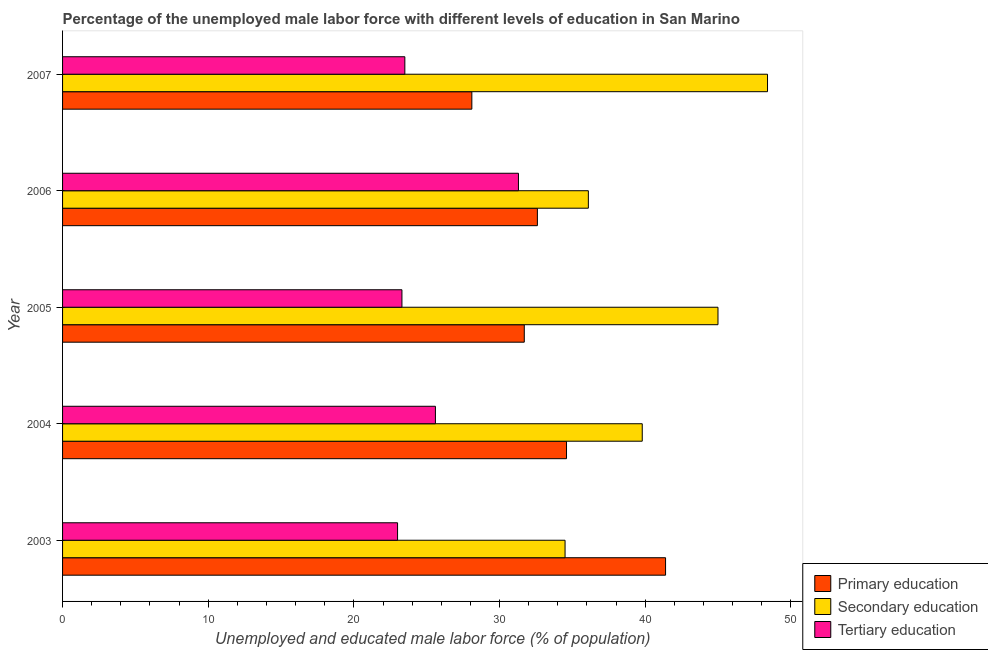Are the number of bars on each tick of the Y-axis equal?
Offer a terse response. Yes. In how many cases, is the number of bars for a given year not equal to the number of legend labels?
Offer a very short reply. 0. What is the percentage of male labor force who received secondary education in 2005?
Provide a succinct answer. 45. Across all years, what is the maximum percentage of male labor force who received primary education?
Your answer should be compact. 41.4. Across all years, what is the minimum percentage of male labor force who received secondary education?
Offer a very short reply. 34.5. In which year was the percentage of male labor force who received tertiary education maximum?
Provide a short and direct response. 2006. What is the total percentage of male labor force who received secondary education in the graph?
Give a very brief answer. 203.8. What is the difference between the percentage of male labor force who received tertiary education in 2003 and the percentage of male labor force who received primary education in 2005?
Keep it short and to the point. -8.7. What is the average percentage of male labor force who received tertiary education per year?
Provide a succinct answer. 25.34. In the year 2006, what is the difference between the percentage of male labor force who received primary education and percentage of male labor force who received tertiary education?
Your response must be concise. 1.3. What is the ratio of the percentage of male labor force who received primary education in 2004 to that in 2006?
Give a very brief answer. 1.06. Is the percentage of male labor force who received primary education in 2005 less than that in 2006?
Your answer should be compact. Yes. Is the difference between the percentage of male labor force who received primary education in 2003 and 2007 greater than the difference between the percentage of male labor force who received secondary education in 2003 and 2007?
Offer a terse response. Yes. What is the difference between the highest and the second highest percentage of male labor force who received secondary education?
Your response must be concise. 3.4. What is the difference between the highest and the lowest percentage of male labor force who received primary education?
Provide a short and direct response. 13.3. In how many years, is the percentage of male labor force who received tertiary education greater than the average percentage of male labor force who received tertiary education taken over all years?
Keep it short and to the point. 2. Is the sum of the percentage of male labor force who received secondary education in 2003 and 2006 greater than the maximum percentage of male labor force who received tertiary education across all years?
Ensure brevity in your answer.  Yes. What does the 2nd bar from the top in 2004 represents?
Provide a succinct answer. Secondary education. What does the 3rd bar from the bottom in 2006 represents?
Give a very brief answer. Tertiary education. Are all the bars in the graph horizontal?
Provide a succinct answer. Yes. How many years are there in the graph?
Ensure brevity in your answer.  5. Are the values on the major ticks of X-axis written in scientific E-notation?
Offer a very short reply. No. Does the graph contain grids?
Ensure brevity in your answer.  No. Where does the legend appear in the graph?
Your answer should be compact. Bottom right. How many legend labels are there?
Make the answer very short. 3. What is the title of the graph?
Your answer should be compact. Percentage of the unemployed male labor force with different levels of education in San Marino. Does "Travel services" appear as one of the legend labels in the graph?
Keep it short and to the point. No. What is the label or title of the X-axis?
Your answer should be very brief. Unemployed and educated male labor force (% of population). What is the Unemployed and educated male labor force (% of population) of Primary education in 2003?
Keep it short and to the point. 41.4. What is the Unemployed and educated male labor force (% of population) in Secondary education in 2003?
Keep it short and to the point. 34.5. What is the Unemployed and educated male labor force (% of population) of Tertiary education in 2003?
Make the answer very short. 23. What is the Unemployed and educated male labor force (% of population) of Primary education in 2004?
Your answer should be compact. 34.6. What is the Unemployed and educated male labor force (% of population) of Secondary education in 2004?
Offer a very short reply. 39.8. What is the Unemployed and educated male labor force (% of population) in Tertiary education in 2004?
Give a very brief answer. 25.6. What is the Unemployed and educated male labor force (% of population) of Primary education in 2005?
Ensure brevity in your answer.  31.7. What is the Unemployed and educated male labor force (% of population) in Tertiary education in 2005?
Provide a short and direct response. 23.3. What is the Unemployed and educated male labor force (% of population) in Primary education in 2006?
Make the answer very short. 32.6. What is the Unemployed and educated male labor force (% of population) in Secondary education in 2006?
Give a very brief answer. 36.1. What is the Unemployed and educated male labor force (% of population) of Tertiary education in 2006?
Provide a succinct answer. 31.3. What is the Unemployed and educated male labor force (% of population) in Primary education in 2007?
Your response must be concise. 28.1. What is the Unemployed and educated male labor force (% of population) in Secondary education in 2007?
Provide a short and direct response. 48.4. What is the Unemployed and educated male labor force (% of population) of Tertiary education in 2007?
Your answer should be very brief. 23.5. Across all years, what is the maximum Unemployed and educated male labor force (% of population) in Primary education?
Your answer should be compact. 41.4. Across all years, what is the maximum Unemployed and educated male labor force (% of population) in Secondary education?
Make the answer very short. 48.4. Across all years, what is the maximum Unemployed and educated male labor force (% of population) in Tertiary education?
Offer a terse response. 31.3. Across all years, what is the minimum Unemployed and educated male labor force (% of population) in Primary education?
Ensure brevity in your answer.  28.1. Across all years, what is the minimum Unemployed and educated male labor force (% of population) in Secondary education?
Make the answer very short. 34.5. What is the total Unemployed and educated male labor force (% of population) of Primary education in the graph?
Offer a terse response. 168.4. What is the total Unemployed and educated male labor force (% of population) in Secondary education in the graph?
Your response must be concise. 203.8. What is the total Unemployed and educated male labor force (% of population) of Tertiary education in the graph?
Keep it short and to the point. 126.7. What is the difference between the Unemployed and educated male labor force (% of population) in Primary education in 2003 and that in 2004?
Provide a short and direct response. 6.8. What is the difference between the Unemployed and educated male labor force (% of population) in Tertiary education in 2003 and that in 2004?
Provide a succinct answer. -2.6. What is the difference between the Unemployed and educated male labor force (% of population) in Secondary education in 2003 and that in 2005?
Offer a very short reply. -10.5. What is the difference between the Unemployed and educated male labor force (% of population) in Primary education in 2003 and that in 2006?
Your answer should be compact. 8.8. What is the difference between the Unemployed and educated male labor force (% of population) in Primary education in 2003 and that in 2007?
Keep it short and to the point. 13.3. What is the difference between the Unemployed and educated male labor force (% of population) of Primary education in 2004 and that in 2005?
Your response must be concise. 2.9. What is the difference between the Unemployed and educated male labor force (% of population) in Secondary education in 2004 and that in 2005?
Give a very brief answer. -5.2. What is the difference between the Unemployed and educated male labor force (% of population) in Tertiary education in 2004 and that in 2005?
Offer a very short reply. 2.3. What is the difference between the Unemployed and educated male labor force (% of population) in Primary education in 2004 and that in 2006?
Offer a very short reply. 2. What is the difference between the Unemployed and educated male labor force (% of population) in Secondary education in 2004 and that in 2006?
Provide a short and direct response. 3.7. What is the difference between the Unemployed and educated male labor force (% of population) of Primary education in 2004 and that in 2007?
Make the answer very short. 6.5. What is the difference between the Unemployed and educated male labor force (% of population) of Primary education in 2005 and that in 2006?
Give a very brief answer. -0.9. What is the difference between the Unemployed and educated male labor force (% of population) of Secondary education in 2005 and that in 2006?
Ensure brevity in your answer.  8.9. What is the difference between the Unemployed and educated male labor force (% of population) in Primary education in 2005 and that in 2007?
Give a very brief answer. 3.6. What is the difference between the Unemployed and educated male labor force (% of population) of Secondary education in 2005 and that in 2007?
Your answer should be compact. -3.4. What is the difference between the Unemployed and educated male labor force (% of population) in Primary education in 2006 and that in 2007?
Your answer should be compact. 4.5. What is the difference between the Unemployed and educated male labor force (% of population) of Secondary education in 2006 and that in 2007?
Your answer should be compact. -12.3. What is the difference between the Unemployed and educated male labor force (% of population) in Primary education in 2003 and the Unemployed and educated male labor force (% of population) in Secondary education in 2004?
Your answer should be very brief. 1.6. What is the difference between the Unemployed and educated male labor force (% of population) in Primary education in 2003 and the Unemployed and educated male labor force (% of population) in Tertiary education in 2004?
Offer a terse response. 15.8. What is the difference between the Unemployed and educated male labor force (% of population) of Primary education in 2003 and the Unemployed and educated male labor force (% of population) of Tertiary education in 2005?
Provide a succinct answer. 18.1. What is the difference between the Unemployed and educated male labor force (% of population) of Secondary education in 2003 and the Unemployed and educated male labor force (% of population) of Tertiary education in 2005?
Provide a short and direct response. 11.2. What is the difference between the Unemployed and educated male labor force (% of population) in Primary education in 2003 and the Unemployed and educated male labor force (% of population) in Secondary education in 2006?
Your answer should be very brief. 5.3. What is the difference between the Unemployed and educated male labor force (% of population) of Primary education in 2003 and the Unemployed and educated male labor force (% of population) of Tertiary education in 2006?
Give a very brief answer. 10.1. What is the difference between the Unemployed and educated male labor force (% of population) in Primary education in 2003 and the Unemployed and educated male labor force (% of population) in Secondary education in 2007?
Provide a short and direct response. -7. What is the difference between the Unemployed and educated male labor force (% of population) of Primary education in 2003 and the Unemployed and educated male labor force (% of population) of Tertiary education in 2007?
Offer a very short reply. 17.9. What is the difference between the Unemployed and educated male labor force (% of population) of Primary education in 2004 and the Unemployed and educated male labor force (% of population) of Secondary education in 2005?
Give a very brief answer. -10.4. What is the difference between the Unemployed and educated male labor force (% of population) in Secondary education in 2004 and the Unemployed and educated male labor force (% of population) in Tertiary education in 2006?
Provide a succinct answer. 8.5. What is the difference between the Unemployed and educated male labor force (% of population) in Secondary education in 2004 and the Unemployed and educated male labor force (% of population) in Tertiary education in 2007?
Ensure brevity in your answer.  16.3. What is the difference between the Unemployed and educated male labor force (% of population) of Primary education in 2005 and the Unemployed and educated male labor force (% of population) of Tertiary education in 2006?
Offer a very short reply. 0.4. What is the difference between the Unemployed and educated male labor force (% of population) in Primary education in 2005 and the Unemployed and educated male labor force (% of population) in Secondary education in 2007?
Provide a succinct answer. -16.7. What is the difference between the Unemployed and educated male labor force (% of population) in Primary education in 2005 and the Unemployed and educated male labor force (% of population) in Tertiary education in 2007?
Keep it short and to the point. 8.2. What is the difference between the Unemployed and educated male labor force (% of population) in Secondary education in 2005 and the Unemployed and educated male labor force (% of population) in Tertiary education in 2007?
Keep it short and to the point. 21.5. What is the difference between the Unemployed and educated male labor force (% of population) of Primary education in 2006 and the Unemployed and educated male labor force (% of population) of Secondary education in 2007?
Your response must be concise. -15.8. What is the difference between the Unemployed and educated male labor force (% of population) in Secondary education in 2006 and the Unemployed and educated male labor force (% of population) in Tertiary education in 2007?
Provide a succinct answer. 12.6. What is the average Unemployed and educated male labor force (% of population) in Primary education per year?
Your answer should be very brief. 33.68. What is the average Unemployed and educated male labor force (% of population) in Secondary education per year?
Give a very brief answer. 40.76. What is the average Unemployed and educated male labor force (% of population) of Tertiary education per year?
Your answer should be very brief. 25.34. In the year 2003, what is the difference between the Unemployed and educated male labor force (% of population) in Primary education and Unemployed and educated male labor force (% of population) in Secondary education?
Your answer should be compact. 6.9. In the year 2004, what is the difference between the Unemployed and educated male labor force (% of population) of Primary education and Unemployed and educated male labor force (% of population) of Secondary education?
Your answer should be compact. -5.2. In the year 2004, what is the difference between the Unemployed and educated male labor force (% of population) in Secondary education and Unemployed and educated male labor force (% of population) in Tertiary education?
Offer a very short reply. 14.2. In the year 2005, what is the difference between the Unemployed and educated male labor force (% of population) in Primary education and Unemployed and educated male labor force (% of population) in Secondary education?
Provide a short and direct response. -13.3. In the year 2005, what is the difference between the Unemployed and educated male labor force (% of population) in Primary education and Unemployed and educated male labor force (% of population) in Tertiary education?
Ensure brevity in your answer.  8.4. In the year 2005, what is the difference between the Unemployed and educated male labor force (% of population) of Secondary education and Unemployed and educated male labor force (% of population) of Tertiary education?
Provide a succinct answer. 21.7. In the year 2006, what is the difference between the Unemployed and educated male labor force (% of population) in Primary education and Unemployed and educated male labor force (% of population) in Secondary education?
Give a very brief answer. -3.5. In the year 2007, what is the difference between the Unemployed and educated male labor force (% of population) in Primary education and Unemployed and educated male labor force (% of population) in Secondary education?
Ensure brevity in your answer.  -20.3. In the year 2007, what is the difference between the Unemployed and educated male labor force (% of population) of Secondary education and Unemployed and educated male labor force (% of population) of Tertiary education?
Ensure brevity in your answer.  24.9. What is the ratio of the Unemployed and educated male labor force (% of population) of Primary education in 2003 to that in 2004?
Give a very brief answer. 1.2. What is the ratio of the Unemployed and educated male labor force (% of population) in Secondary education in 2003 to that in 2004?
Your answer should be very brief. 0.87. What is the ratio of the Unemployed and educated male labor force (% of population) of Tertiary education in 2003 to that in 2004?
Offer a terse response. 0.9. What is the ratio of the Unemployed and educated male labor force (% of population) of Primary education in 2003 to that in 2005?
Your answer should be very brief. 1.31. What is the ratio of the Unemployed and educated male labor force (% of population) of Secondary education in 2003 to that in 2005?
Offer a terse response. 0.77. What is the ratio of the Unemployed and educated male labor force (% of population) in Tertiary education in 2003 to that in 2005?
Your answer should be very brief. 0.99. What is the ratio of the Unemployed and educated male labor force (% of population) in Primary education in 2003 to that in 2006?
Make the answer very short. 1.27. What is the ratio of the Unemployed and educated male labor force (% of population) of Secondary education in 2003 to that in 2006?
Offer a terse response. 0.96. What is the ratio of the Unemployed and educated male labor force (% of population) of Tertiary education in 2003 to that in 2006?
Provide a short and direct response. 0.73. What is the ratio of the Unemployed and educated male labor force (% of population) of Primary education in 2003 to that in 2007?
Make the answer very short. 1.47. What is the ratio of the Unemployed and educated male labor force (% of population) in Secondary education in 2003 to that in 2007?
Provide a succinct answer. 0.71. What is the ratio of the Unemployed and educated male labor force (% of population) of Tertiary education in 2003 to that in 2007?
Provide a succinct answer. 0.98. What is the ratio of the Unemployed and educated male labor force (% of population) of Primary education in 2004 to that in 2005?
Your answer should be compact. 1.09. What is the ratio of the Unemployed and educated male labor force (% of population) of Secondary education in 2004 to that in 2005?
Provide a succinct answer. 0.88. What is the ratio of the Unemployed and educated male labor force (% of population) in Tertiary education in 2004 to that in 2005?
Keep it short and to the point. 1.1. What is the ratio of the Unemployed and educated male labor force (% of population) in Primary education in 2004 to that in 2006?
Provide a succinct answer. 1.06. What is the ratio of the Unemployed and educated male labor force (% of population) of Secondary education in 2004 to that in 2006?
Your response must be concise. 1.1. What is the ratio of the Unemployed and educated male labor force (% of population) in Tertiary education in 2004 to that in 2006?
Keep it short and to the point. 0.82. What is the ratio of the Unemployed and educated male labor force (% of population) in Primary education in 2004 to that in 2007?
Provide a short and direct response. 1.23. What is the ratio of the Unemployed and educated male labor force (% of population) of Secondary education in 2004 to that in 2007?
Your response must be concise. 0.82. What is the ratio of the Unemployed and educated male labor force (% of population) in Tertiary education in 2004 to that in 2007?
Your response must be concise. 1.09. What is the ratio of the Unemployed and educated male labor force (% of population) in Primary education in 2005 to that in 2006?
Your answer should be compact. 0.97. What is the ratio of the Unemployed and educated male labor force (% of population) in Secondary education in 2005 to that in 2006?
Make the answer very short. 1.25. What is the ratio of the Unemployed and educated male labor force (% of population) of Tertiary education in 2005 to that in 2006?
Provide a succinct answer. 0.74. What is the ratio of the Unemployed and educated male labor force (% of population) of Primary education in 2005 to that in 2007?
Make the answer very short. 1.13. What is the ratio of the Unemployed and educated male labor force (% of population) in Secondary education in 2005 to that in 2007?
Provide a short and direct response. 0.93. What is the ratio of the Unemployed and educated male labor force (% of population) in Tertiary education in 2005 to that in 2007?
Your answer should be compact. 0.99. What is the ratio of the Unemployed and educated male labor force (% of population) of Primary education in 2006 to that in 2007?
Your response must be concise. 1.16. What is the ratio of the Unemployed and educated male labor force (% of population) of Secondary education in 2006 to that in 2007?
Ensure brevity in your answer.  0.75. What is the ratio of the Unemployed and educated male labor force (% of population) in Tertiary education in 2006 to that in 2007?
Give a very brief answer. 1.33. What is the difference between the highest and the lowest Unemployed and educated male labor force (% of population) of Primary education?
Make the answer very short. 13.3. What is the difference between the highest and the lowest Unemployed and educated male labor force (% of population) of Secondary education?
Offer a terse response. 13.9. 